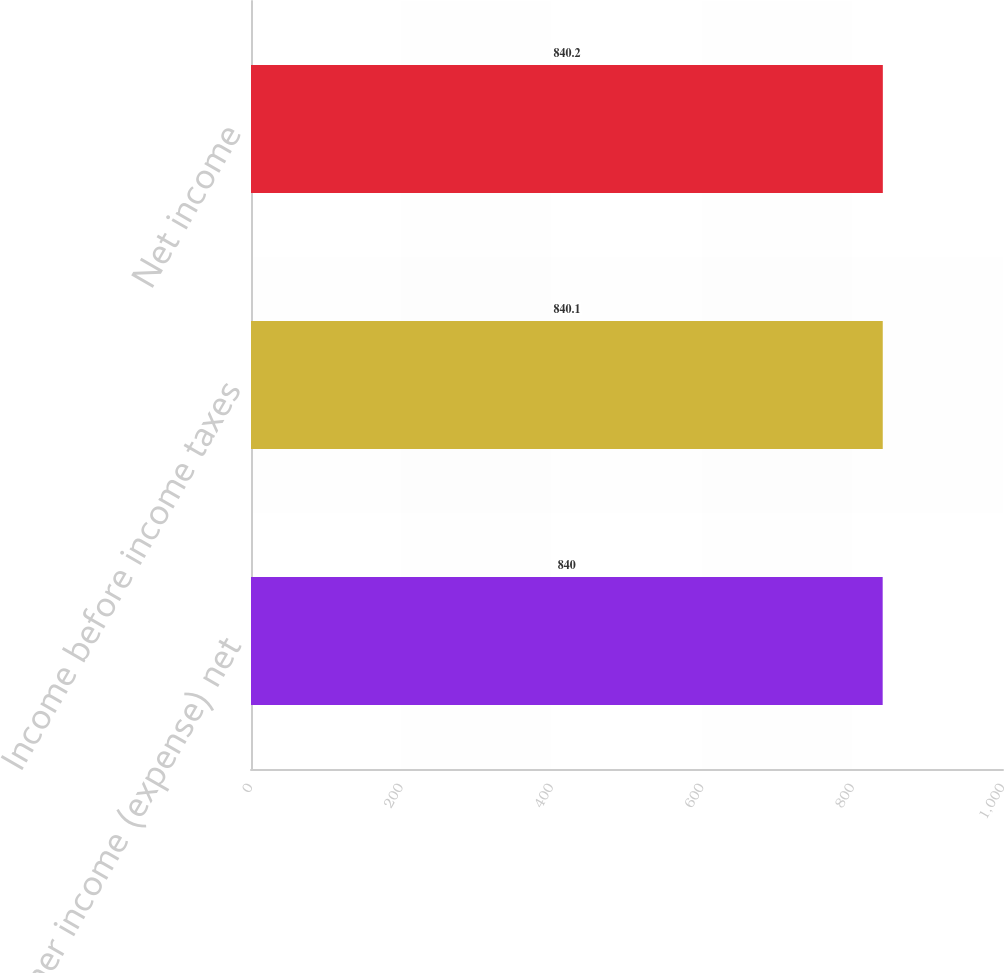Convert chart. <chart><loc_0><loc_0><loc_500><loc_500><bar_chart><fcel>Other income (expense) net<fcel>Income before income taxes<fcel>Net income<nl><fcel>840<fcel>840.1<fcel>840.2<nl></chart> 